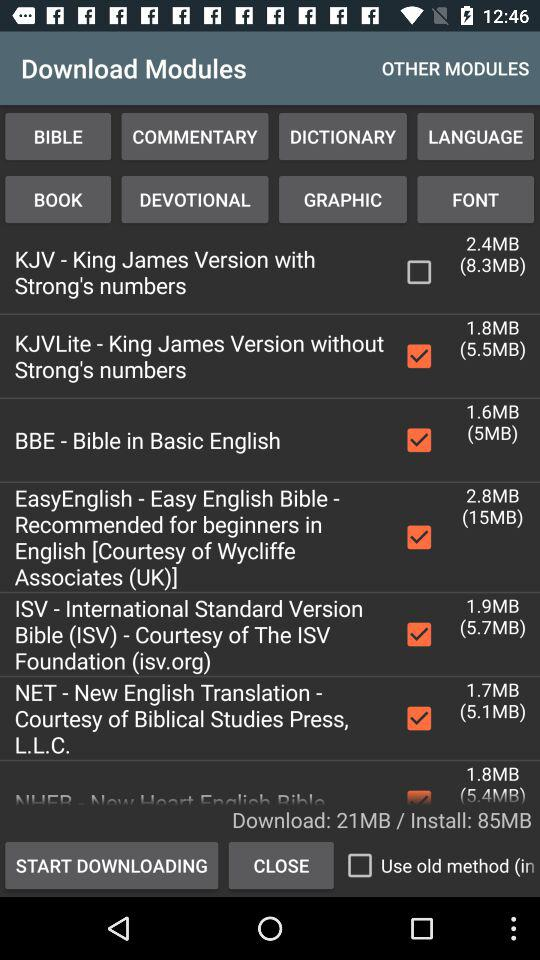How many MB does the smallest module have?
Answer the question using a single word or phrase. 1.6MB 